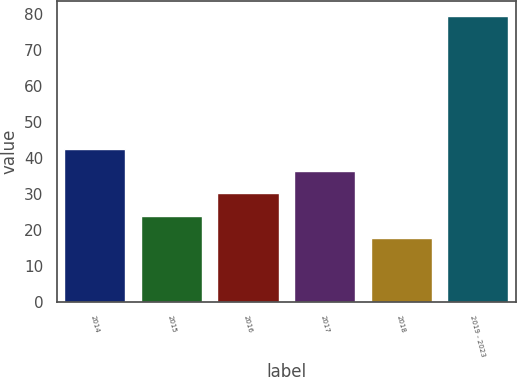<chart> <loc_0><loc_0><loc_500><loc_500><bar_chart><fcel>2014<fcel>2015<fcel>2016<fcel>2017<fcel>2018<fcel>2019 - 2023<nl><fcel>42.42<fcel>23.88<fcel>30.06<fcel>36.24<fcel>17.7<fcel>79.5<nl></chart> 